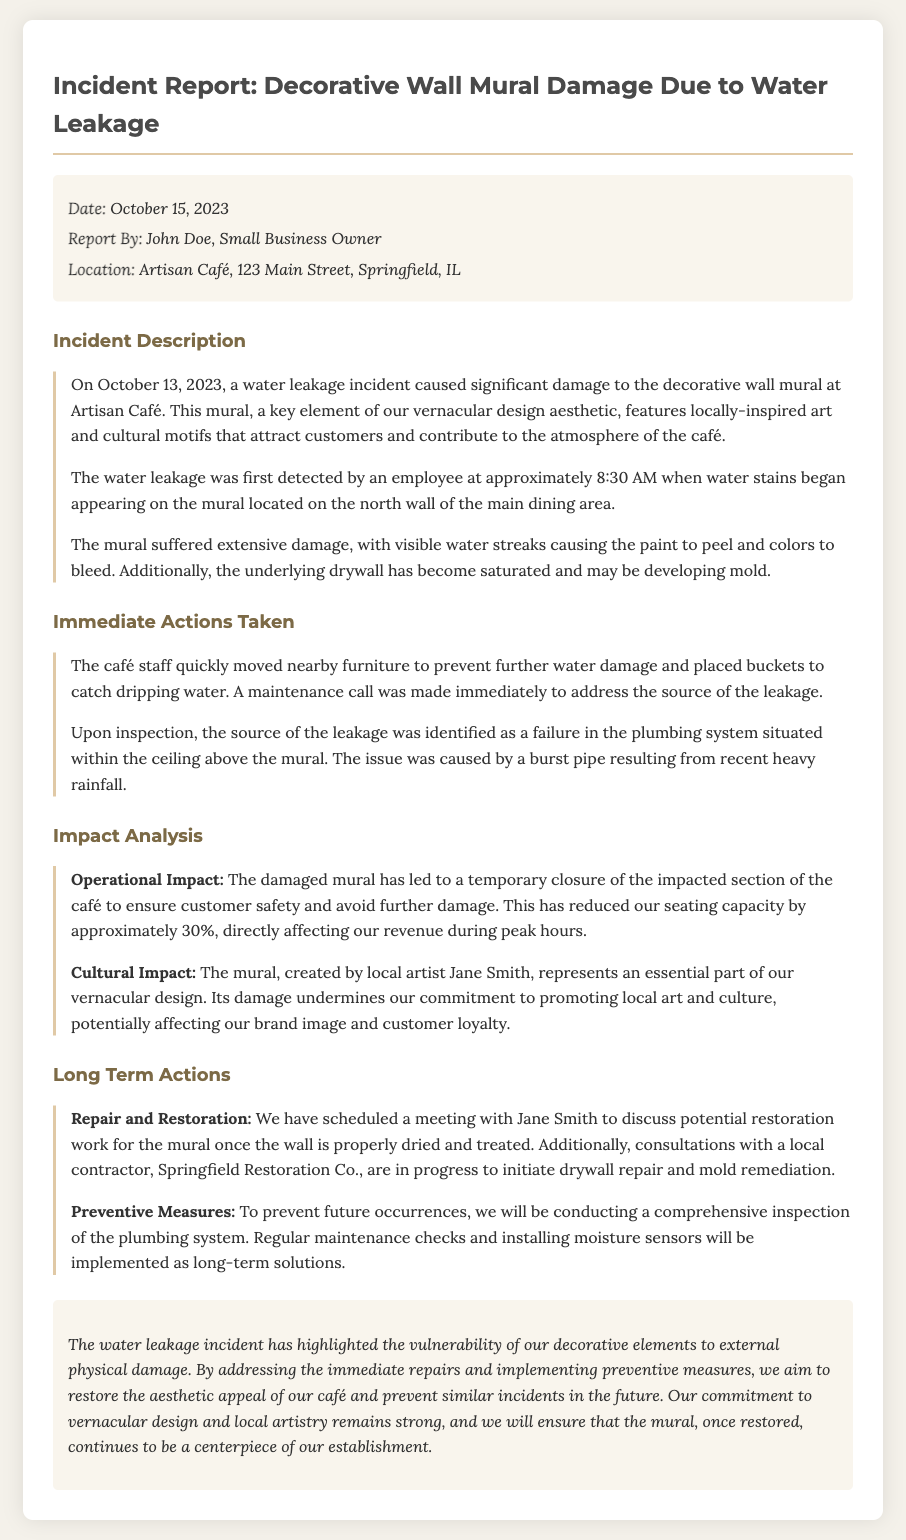what date did the incident occur? The incident occurred on October 13, 2023.
Answer: October 13, 2023 who identified the source of the leakage? The source of the leakage was identified upon inspection, which typically involves maintenance staff or building management.
Answer: Maintenance staff what was the immediate action taken by the café staff? The café staff took immediate actions to prevent further damage such as moving furniture and placing buckets.
Answer: Moved nearby furniture what was the impact on seating capacity? The impacted section of the café reduced the seating capacity by approximately 30%.
Answer: 30% who created the mural? The mural was created by local artist Jane Smith.
Answer: Jane Smith what preventive measure will be implemented? One of the preventive measures mentioned is conducting a comprehensive inspection of the plumbing system.
Answer: Plumbing inspection where is the incident location? The location of the incident is stated to be at Artisan Café, 123 Main Street, Springfield, IL.
Answer: Artisan Café, 123 Main Street, Springfield, IL what type of artistic style does the mural represent? The mural represents a vernacular design aesthetic featuring locally-inspired art and cultural motifs.
Answer: Vernacular design what action is planned for the restoration of the mural? A meeting has been scheduled with Jane Smith to discuss potential restoration work for the mural.
Answer: Meeting with Jane Smith 